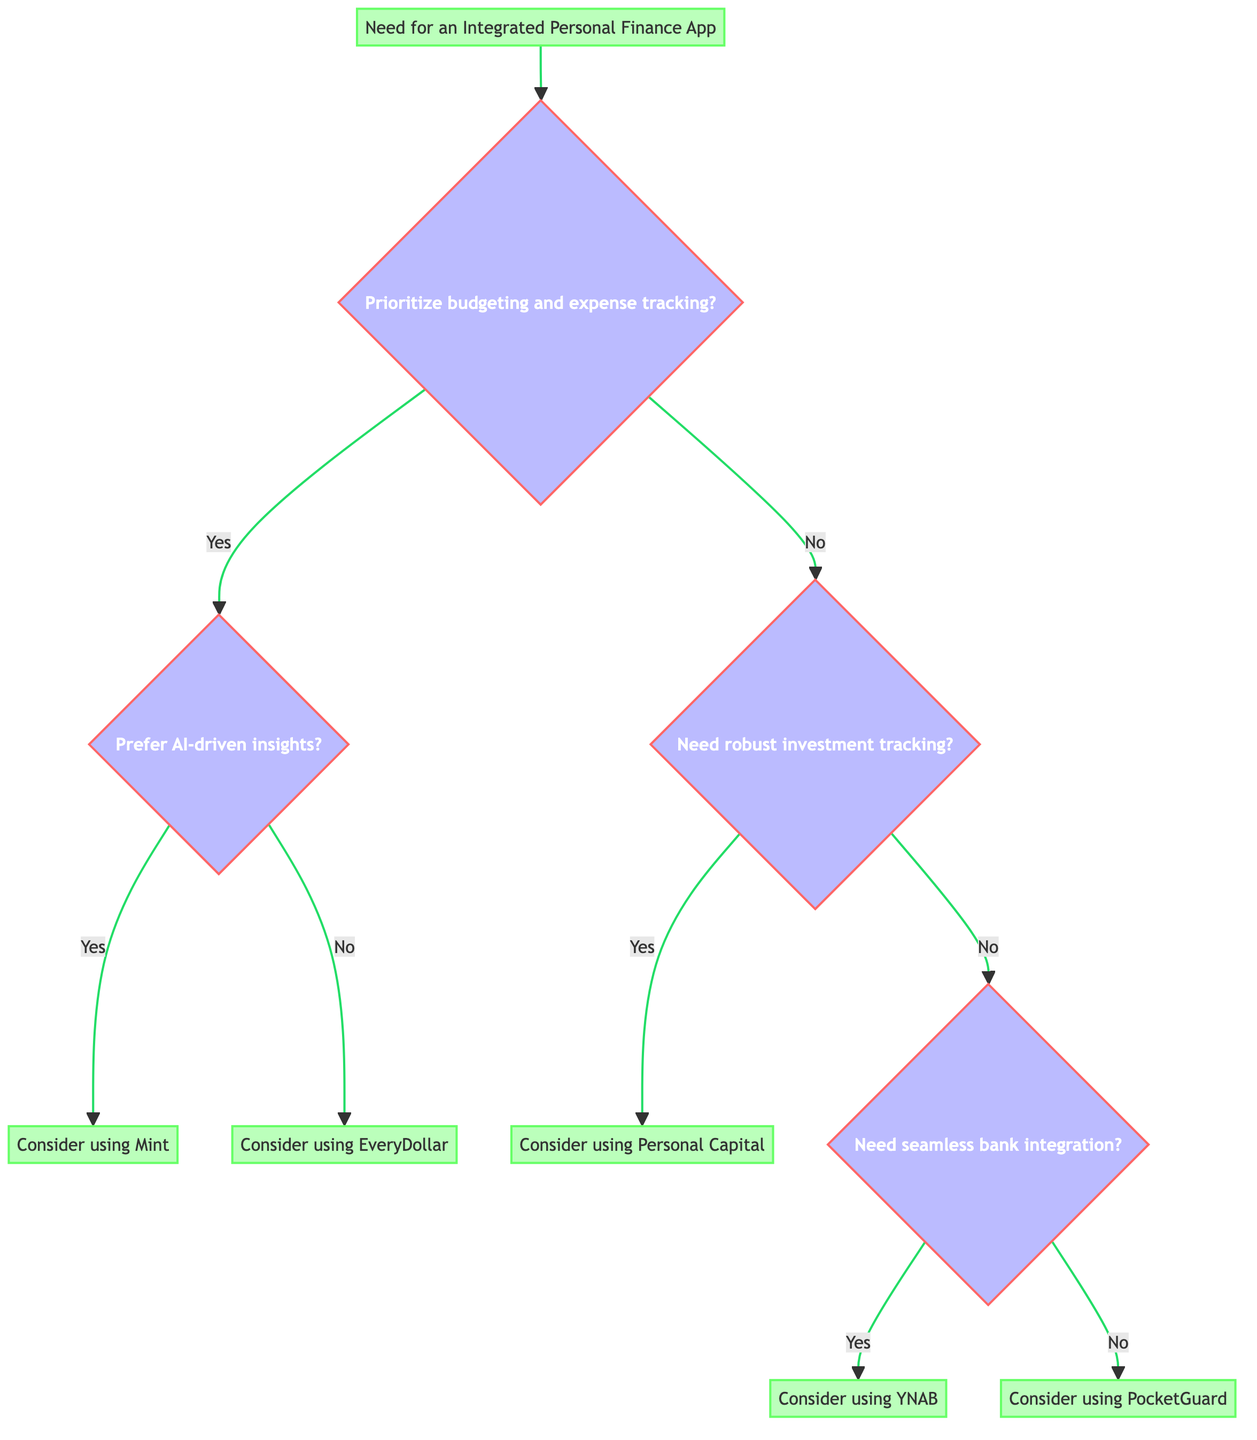What is the starting point of the decision tree? The starting point of the decision tree is labeled as "Need for an Integrated Personal Finance App." This is clearly shown as the initial node from which all other decision points branch out.
Answer: Need for an Integrated Personal Finance App How many decision points are there in total? There are four decision points in the diagram: one at the beginning (budgeting and expense tracking), followed by three subsequent questions regarding AI insights, investment tracking, and bank account integration.
Answer: Four What app is recommended if you prefer AI-driven insights? If you prefer AI-driven insights, the decision tree indicates that you should consider using "Mint." This result follows the path from the budgeting question to the AI insights question leading to Mint.
Answer: Mint If you answer "No" to needing robust investment tracking, which app is suggested if you also need seamless integration with bank accounts? If you answer "No" to robust investment tracking and "Yes" to needing seamless bank integration, then the app recommended would be "YNAB (You Need a Budget)." Following the path from the decision tree leads to this result.
Answer: YNAB (You Need a Budget) What is the final recommendation if you prioritize budgeting but do not prefer AI-driven insights? If you prioritize budgeting but do not prefer AI-driven insights, the diagram shows that you should consider using "EveryDollar." Following the decision path for this scenario directly leads to this app.
Answer: EveryDollar What happens if you do not need robust investment tracking and answer "No" to seamless integration with bank accounts? If you answer "No" to needing robust investment tracking and also "No" to needing seamless integration, the last recommendation on that path is "PocketGuard." This concludes the decision process in that scenario.
Answer: PocketGuard How many apps are suggested in total at the end of the decision process? There are five distinct apps suggested at the end of the decision tree: Mint, EveryDollar, Personal Capital, YNAB, and PocketGuard. Each app corresponds to different decision paths.
Answer: Five Which apps are associated with the decision nodes for "No" answers in budgeting and expense tracking? The apps associated with "No" answers in budgeting tracking are "Personal Capital" (if robust investment tracking is needed) and "PocketGuard" (if not needing robust investment tracking and seamless bank integration). Therefore, they are linked directly from those decision nodes.
Answer: Personal Capital, PocketGuard What does the "Yes" response to the question about seamless integration with bank accounts lead to? A "Yes" response to the question about seamless bank integration leads directly to the recommendation of using "YNAB." This is a clear outcome from following that specific path in the decision tree.
Answer: YNAB 